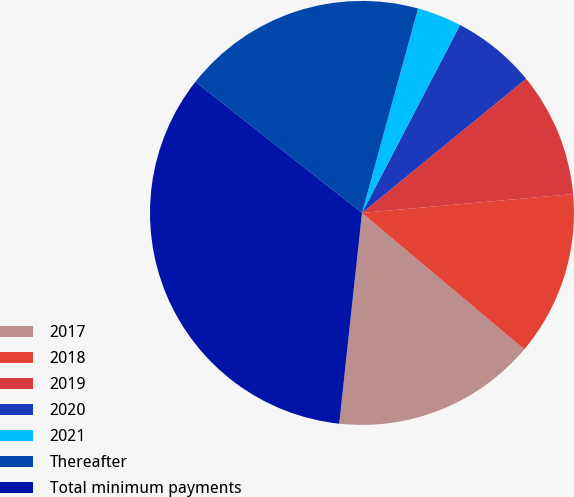<chart> <loc_0><loc_0><loc_500><loc_500><pie_chart><fcel>2017<fcel>2018<fcel>2019<fcel>2020<fcel>2021<fcel>Thereafter<fcel>Total minimum payments<nl><fcel>15.59%<fcel>12.54%<fcel>9.49%<fcel>6.44%<fcel>3.39%<fcel>18.65%<fcel>33.9%<nl></chart> 